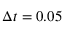Convert formula to latex. <formula><loc_0><loc_0><loc_500><loc_500>\Delta t = 0 . 0 5</formula> 